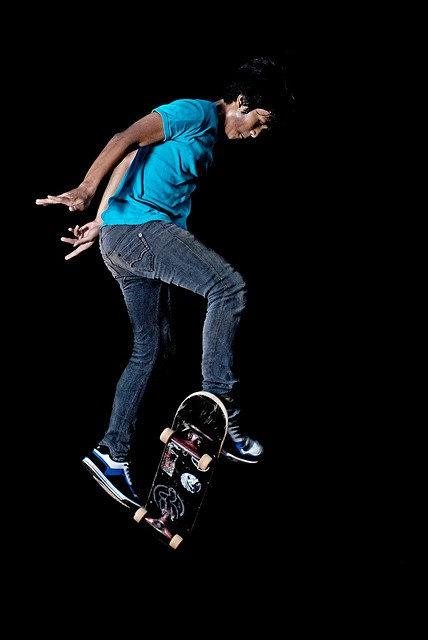Describe the objects in this image and their specific colors. I can see people in black, navy, blue, and gray tones and skateboard in black, gray, lightgray, and darkgray tones in this image. 